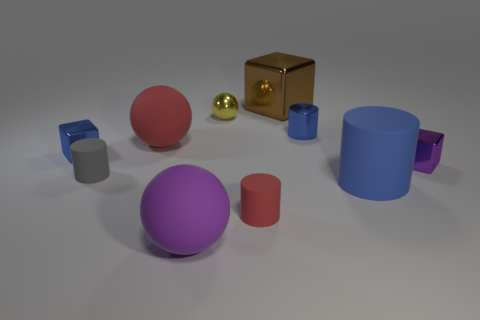Subtract all red rubber spheres. How many spheres are left? 2 Subtract all red cylinders. How many cylinders are left? 3 Subtract 1 cubes. How many cubes are left? 2 Subtract all brown cylinders. Subtract all purple balls. How many cylinders are left? 4 Subtract all balls. How many objects are left? 7 Add 4 blue blocks. How many blue blocks are left? 5 Add 3 large blue matte cylinders. How many large blue matte cylinders exist? 4 Subtract 1 yellow spheres. How many objects are left? 9 Subtract all tiny gray matte objects. Subtract all tiny metallic cylinders. How many objects are left? 8 